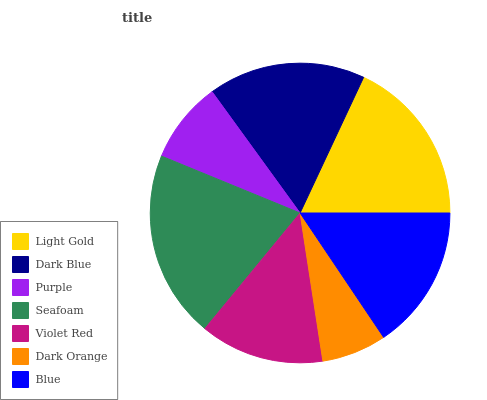Is Dark Orange the minimum?
Answer yes or no. Yes. Is Seafoam the maximum?
Answer yes or no. Yes. Is Dark Blue the minimum?
Answer yes or no. No. Is Dark Blue the maximum?
Answer yes or no. No. Is Light Gold greater than Dark Blue?
Answer yes or no. Yes. Is Dark Blue less than Light Gold?
Answer yes or no. Yes. Is Dark Blue greater than Light Gold?
Answer yes or no. No. Is Light Gold less than Dark Blue?
Answer yes or no. No. Is Blue the high median?
Answer yes or no. Yes. Is Blue the low median?
Answer yes or no. Yes. Is Purple the high median?
Answer yes or no. No. Is Light Gold the low median?
Answer yes or no. No. 